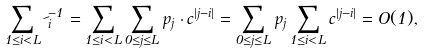<formula> <loc_0><loc_0><loc_500><loc_500>\sum _ { 1 \leq i < L } \psi _ { i } ^ { - 1 } = \sum _ { 1 \leq i < L } { \sum _ { 0 \leq j \leq L } p _ { j } \cdot c ^ { | j - i | } } = \sum _ { 0 \leq j \leq L } p _ { j } \sum _ { 1 \leq i < L } c ^ { | j - i | } = O ( 1 ) ,</formula> 